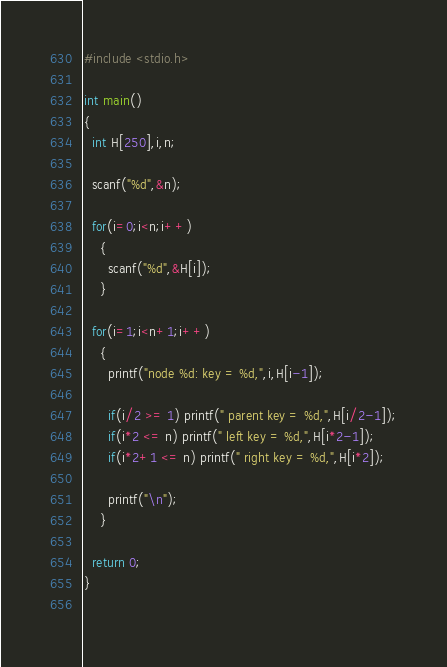<code> <loc_0><loc_0><loc_500><loc_500><_C_>#include <stdio.h>

int main()
{
  int H[250],i,n;

  scanf("%d",&n);

  for(i=0;i<n;i++)
    {
      scanf("%d",&H[i]);
    }

  for(i=1;i<n+1;i++)
    {
      printf("node %d: key = %d,",i,H[i-1]);

      if(i/2 >= 1) printf(" parent key = %d,",H[i/2-1]);
      if(i*2 <= n) printf(" left key = %d,",H[i*2-1]);
      if(i*2+1 <= n) printf(" right key = %d,",H[i*2]);

      printf("\n");
    }

  return 0;
}
			  </code> 